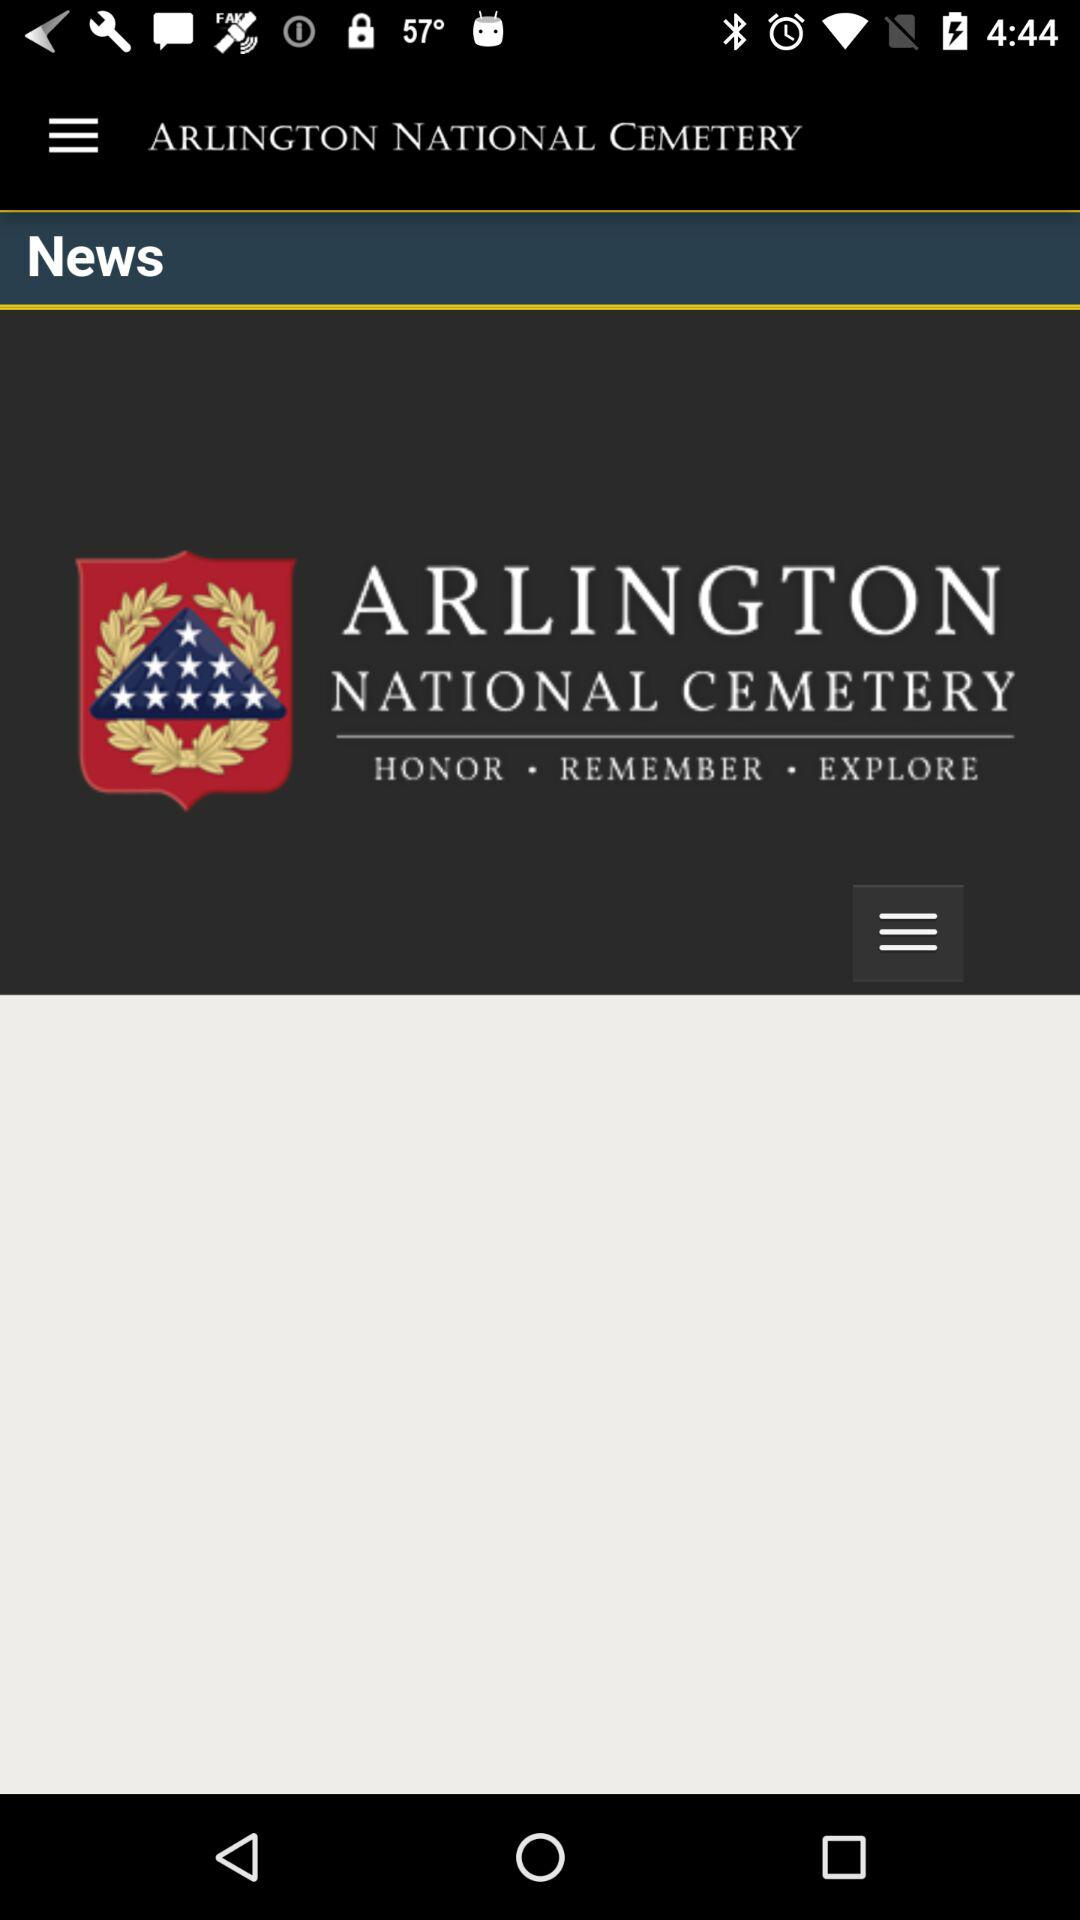What is the name of the application? The name of the application is "ARLINGTON NATIONAL CEMETERY". 